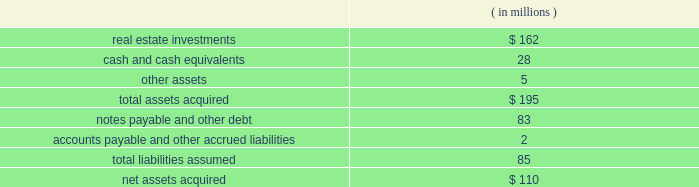Note 6 2014mergers and acquisitions eldertrust merger on february 5 , 2004 , the company consummated a merger transaction in an all cash transaction valued at $ 184 million ( the 201celdertrust transaction 201d ) .
The eldertrust transaction adds nine assisted living facilities , one independent living facility , five skilled nursing facilities , two med- ical office buildings and a financial office building ( the 201celdertrust properties 201d ) to the company 2019s portfolio.the eldertrust properties are leased by the company to various operators under leases providing for aggregated , annual cash base rent of approxi- mately $ 16.2 million , subject to escalation as provided in the leases.the leases have remaining terms primarily ranging from four to 11 years.at the closing of the eldertrust transaction , the company also acquired all of the limited partnership units in eldertrust operating limited partnership ( 201cetop 201d ) directly from their owners at $ 12.50 per unit , excluding 31455 class c units in etop ( which will remain outstanding ) .
Etop owns directly or indirectly all of the eldertrust properties .
The company funded the $ 101 million equity portion of the purchase price with cash on eldertrust 2019s balance sheet , a portion of the $ 85 million in proceeds from its december 2003 sale of ten facilities to kindred and draws on the company 2019s revolving credit facility ( the 201crevolving credit facility 201d ) under its second amended and restated security and guaranty agreement , dated as of april 17 , 2002 ( the 201c2002 credit agreement 201d ) .the company 2019s ownership of the eldertrust properties is subject to approximately $ 83 million of property level debt and other liabilities.at the close of the eldertrust transaction , eldertrust had approximately $ 33.5 million in unrestricted and restricted cash on hand .
The acquisition was accounted for under the purchase method .
The table summarizes the preliminary estimated fair values of the assets acquired and liabilities assumed at the date of acquisition .
Such estimates are subject to refinement as additional valuation information is received .
Operations from this merger will be reflected in the company 2019s consolidated financial state- ments for periods subsequent to the acquisition date of february 5 , 2004.the company is in the process of computing fair values , thus , the allocation of the purchase price is subject to refinement. .
Transaction with brookdale on january 29 , 2004 , the company entered into 14 definitive purchase agreements ( each , a 201cbrookdale purchase agreement 201d ) with certain affiliates of brookdale living communities , inc .
( 201cbrookdale 201d ) to purchase ( each such purchase , a 201cbrookdale acquisition 201d ) a total of 14 independent living or assisted living facilities ( each , a 201cbrookdale facility 201d ) for an aggregate purchase price of $ 115 million.affiliates of brookdale have agreed to lease and operate the brookdale facilities pursuant to one or more triple-net leases.all of the brookdale leases , which have an initial term of 15 years , will be guaranteed by brookdale and provide for aggregated annual base rent of approximately $ 10 million , escalating each year by the greater of ( i ) 1.5% ( 1.5 % ) or ( ii ) 75% ( 75 % ) of the consumer price index .
The company expects to fund the brookdale acquisitions by assuming an aggregate of approximately $ 41 million of non- recourse property level debt on certain of the brookdale facilities , with the balance to be paid from cash on hand and/or draws on the revolving credit facility.the property level debt encumbers seven of the brookdale facilities .
On january 29 , 2004 , the company completed the acquisitions of four brookdale facilities for an aggregate purchase price of $ 37 million.the company 2019s acquisition of the remaining ten brookdale facilities is expected to be completed shortly , subject to customary closing conditions .
However , the consummation of each such brookdale acquisition is not conditioned upon the consummation of any other such brookdale acquisition and there can be no assurance which , if any , of such remaining brookdale acquisitions will be consummated or when they will be consummated .
Transactions with trans healthcare , inc .
On november 4 , 2002 , the company , through its wholly owned subsidiary ventas realty , completed a $ 120.0 million transaction ( the 201cthi transaction 201d ) with trans healthcare , inc. , a privately owned long-term care and hospital company ( 201cthi 201d ) .the thi transaction was structured as a $ 53.0 million sale leaseback trans- action ( the 201cthi sale leaseback 201d ) and a $ 67.0 million loan ( the 201cthi loan 201d ) , comprised of a first mortgage loan ( the 201cthi senior loan 201d ) and a mezzanine loan ( the 201cthi mezzanine loan 201d ) .
Following a sale of the thi senior loan in december 2002 ( see below ) , the company 2019s investment in thi was $ 70.0 million .
As part of the thi sale leasebackventas realty purchased 5 properties and is leasing them back to thi under a 201ctriple-net 201d master lease ( the 201cthi master lease 201d ) .the properties subject to the sale leaseback are four skilled nursing facilities and one con- tinuing care retirement community.the thi master lease , which has an initial term of ten years , provides for annual base rent of $ 5.9 million.the thi master lease provides that if thi meets specified revenue parameters , annual base rent will escalate each year by the greater of ( i ) three percent or ( ii ) 50% ( 50 % ) of the consumer price index .
Ventas , inc .
Page 37 annual report 2003 .
What as the leverage of the debt to assets of elder trust at the time of the to the purchase? 
Rationale: the ratio of the debt to the assets show how much of each dollar invested in debt produces assets
Computations: (85 / 195)
Answer: 0.4359. 